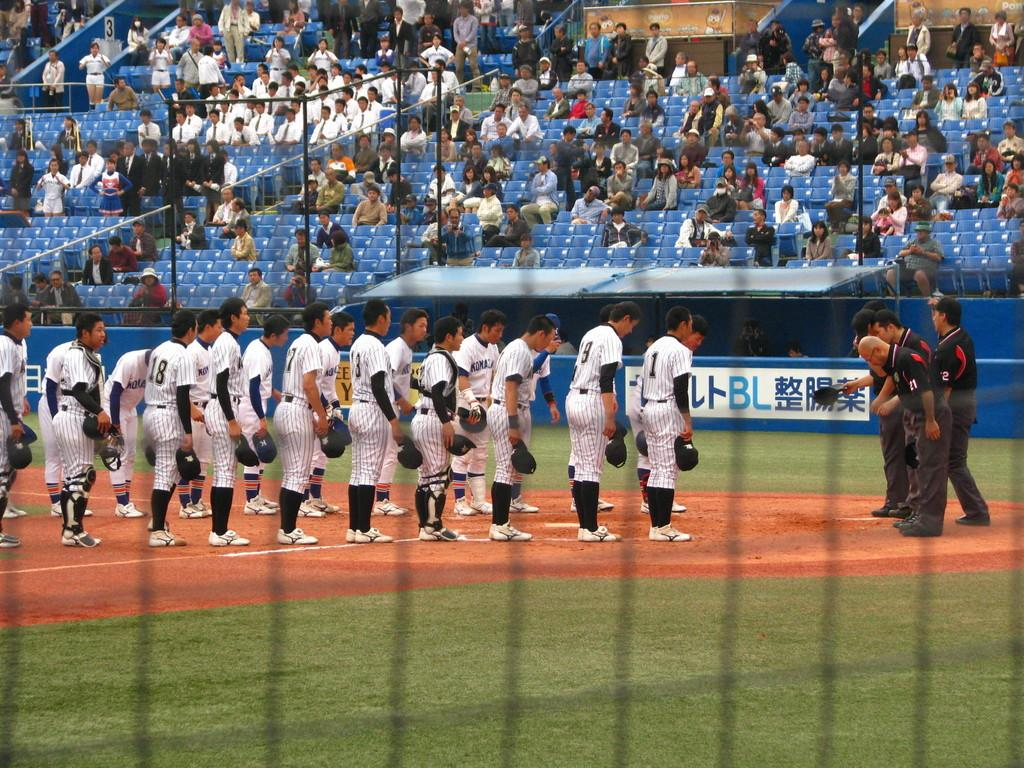<image>
Relay a brief, clear account of the picture shown. Player number 18 stands near the back of the line on the field 